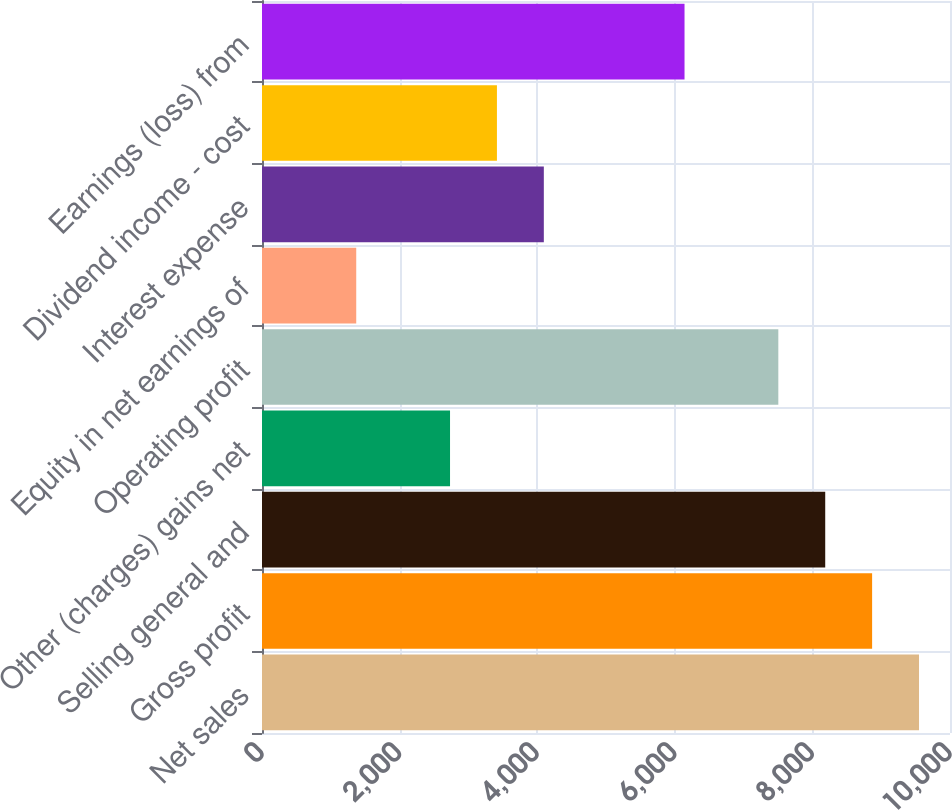<chart> <loc_0><loc_0><loc_500><loc_500><bar_chart><fcel>Net sales<fcel>Gross profit<fcel>Selling general and<fcel>Other (charges) gains net<fcel>Operating profit<fcel>Equity in net earnings of<fcel>Interest expense<fcel>Dividend income - cost<fcel>Earnings (loss) from<nl><fcel>9549.64<fcel>8867.98<fcel>8186.32<fcel>2733.04<fcel>7504.66<fcel>1369.72<fcel>4096.36<fcel>3414.7<fcel>6141.34<nl></chart> 